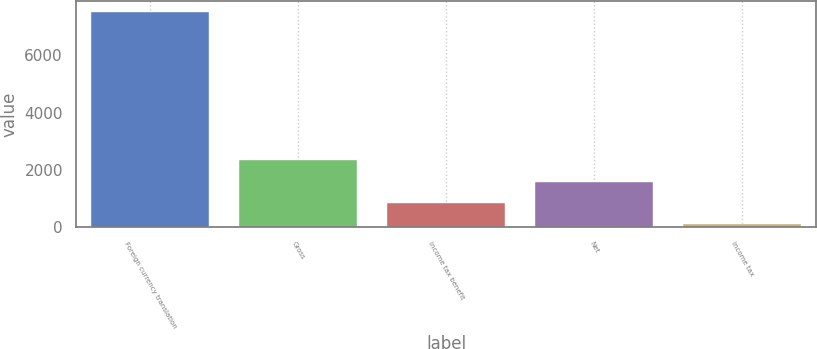<chart> <loc_0><loc_0><loc_500><loc_500><bar_chart><fcel>Foreign currency translation<fcel>Gross<fcel>Income tax benefit<fcel>Net<fcel>Income tax<nl><fcel>7512<fcel>2330.6<fcel>850.2<fcel>1590.4<fcel>110<nl></chart> 